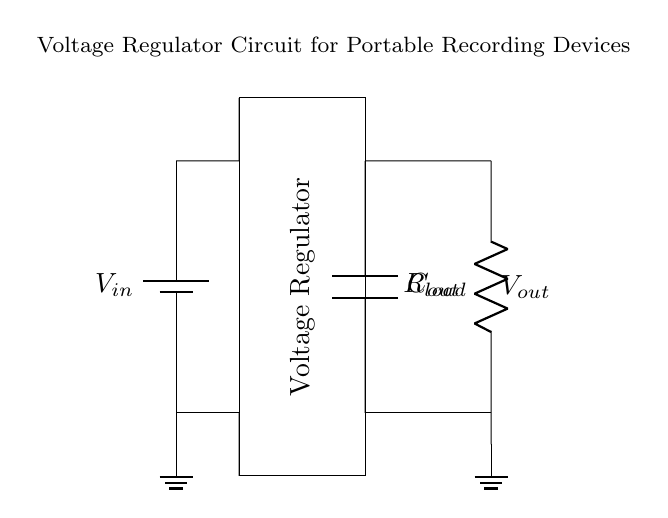What is the input voltage source labeled as? The input voltage source is labeled as V_in, which indicates the voltage supplied to the circuit.
Answer: V_in What is the purpose of the rectangular component at the center? The rectangular component is labeled as "Voltage Regulator" and is responsible for maintaining a constant output voltage despite variations in input voltage or load conditions.
Answer: Voltage Regulator How many capacitors are present in this circuit? There is one capacitor present in the circuit, identified as C_out, connected to the output.
Answer: One What type of load is indicated in the circuit? The load is represented by a resistor labeled as R_load, suggesting that it consumes electrical power and can be modeled as a resistive load.
Answer: Resistor What is the purpose of the capacitor labeled C_out? The capacitor C_out is used to smooth out the output voltage by filtering any fluctuations, helping to provide a stable voltage to the load.
Answer: Smoothing If the input voltage is 9V, what can be inferred about the output voltage? The circuit indicates that it is designed to regulate the output voltage, typically lower than the input, so one could expect a stable voltage at the output, often around values like 5V or 3.3V based on common voltage regulators.
Answer: Regulated voltage (lower than 9V) What does the ground symbol signify in this circuit? The ground symbol indicates the reference point in the circuit for voltage measurements; it is where the voltage is considered zero, providing a common return path for current.
Answer: Ground reference 